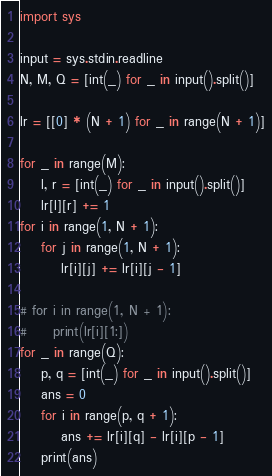<code> <loc_0><loc_0><loc_500><loc_500><_Python_>import sys

input = sys.stdin.readline
N, M, Q = [int(_) for _ in input().split()]

lr = [[0] * (N + 1) for _ in range(N + 1)]

for _ in range(M):
    l, r = [int(_) for _ in input().split()]
    lr[l][r] += 1
for i in range(1, N + 1):
    for j in range(1, N + 1):
        lr[i][j] += lr[i][j - 1]

# for i in range(1, N + 1):
#     print(lr[i][1:])
for _ in range(Q):
    p, q = [int(_) for _ in input().split()]
    ans = 0
    for i in range(p, q + 1):
        ans += lr[i][q] - lr[i][p - 1]
    print(ans)
</code> 